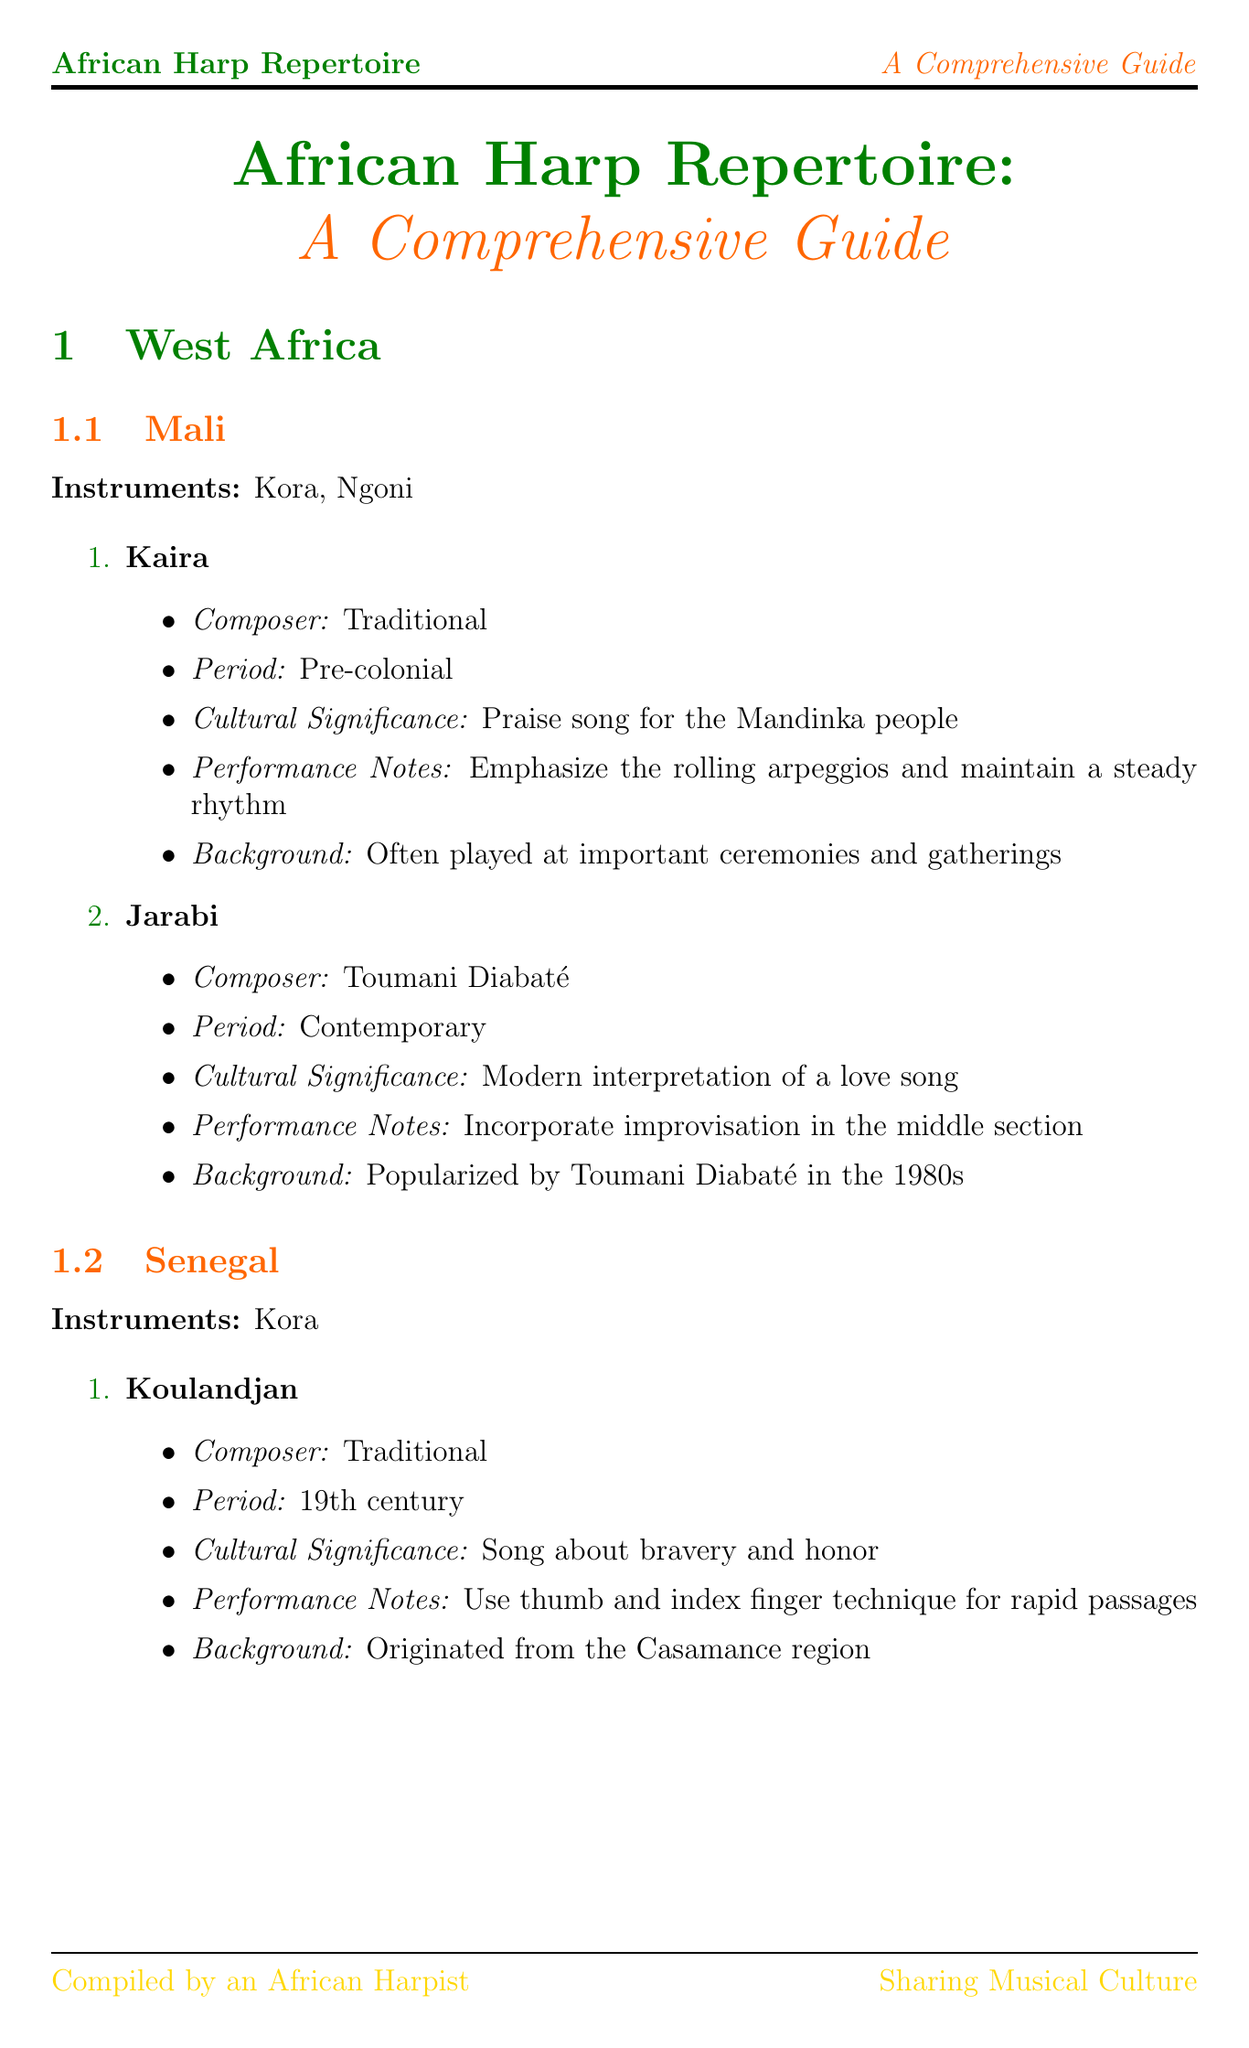What is the title of the manual? The title is explicitly mentioned at the beginning of the document.
Answer: African Harp Repertoire: A Comprehensive Guide How many sections are included in the document? The document lists the main sections, which number a total of four.
Answer: 4 Who composed the piece "Jarabi"? The document specifies the composer of each piece, identifying the creator of "Jarabi."
Answer: Toumani Diabaté What cultural significance is associated with the song "Setinkane"? Each song has a defined cultural significance detailed in the document.
Answer: Used in healing ceremonies What performance technique is common in West African kora playing? The document lists specific performance techniques, highlighting what is common in kora playing.
Answer: Thumb and index plucking Which instrument is used in the song "Aye Mere"? The document indicates the instruments associated with each piece, naming the instrument for "Aye Mere."
Answer: Adungu In what period was the song "Koulandjan" created? The document provides the historical periods associated with each song, specifying the period for "Koulandjan."
Answer: 19th century What is the primary focus of performance notes for "Mwana Talala"? The document lists performance notes which detail how to play each piece, particularly for "Mwana Talala."
Answer: Play softly with gentle plucking Name one notable African harpist from Mali. The document includes a section on notable harpists and their countries, clearly identifying one from Mali.
Answer: Toumani Diabaté 